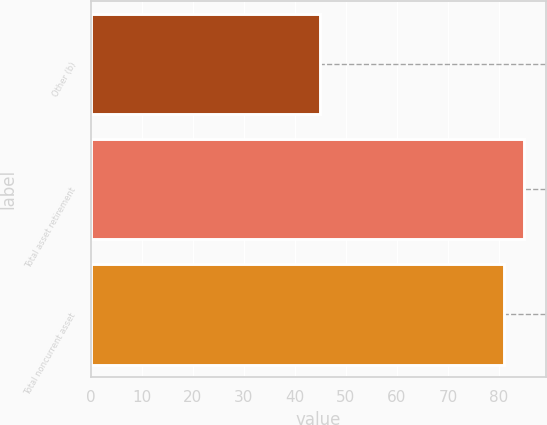Convert chart to OTSL. <chart><loc_0><loc_0><loc_500><loc_500><bar_chart><fcel>Other (b)<fcel>Total asset retirement<fcel>Total noncurrent asset<nl><fcel>45<fcel>84.9<fcel>81<nl></chart> 